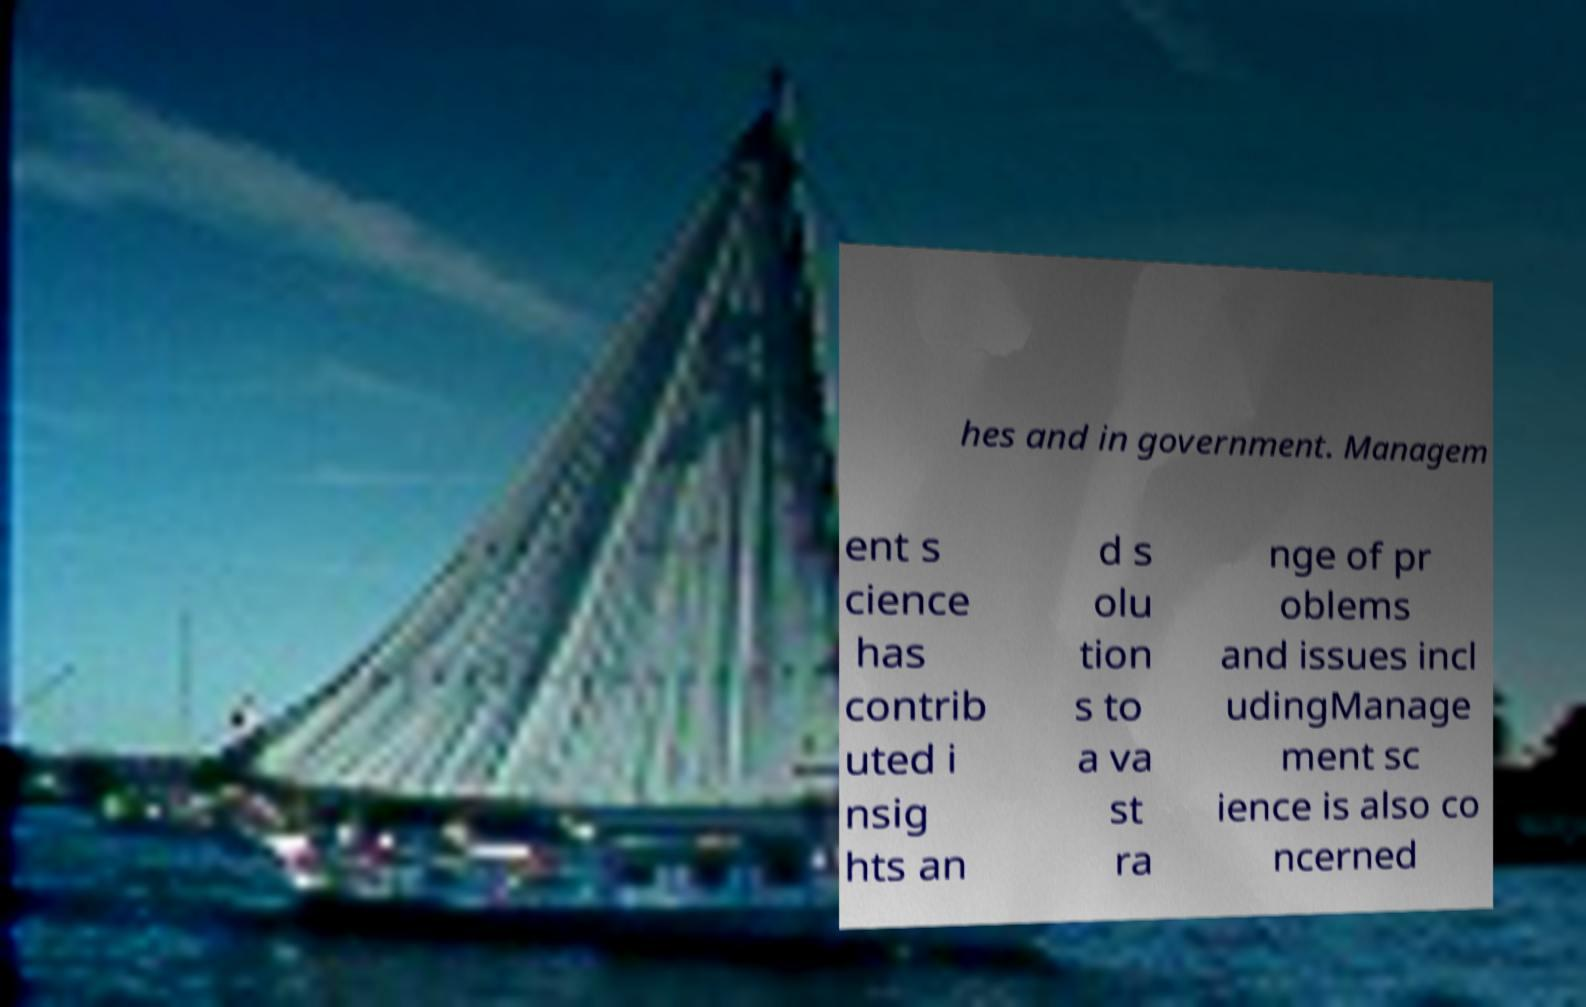Could you assist in decoding the text presented in this image and type it out clearly? hes and in government. Managem ent s cience has contrib uted i nsig hts an d s olu tion s to a va st ra nge of pr oblems and issues incl udingManage ment sc ience is also co ncerned 